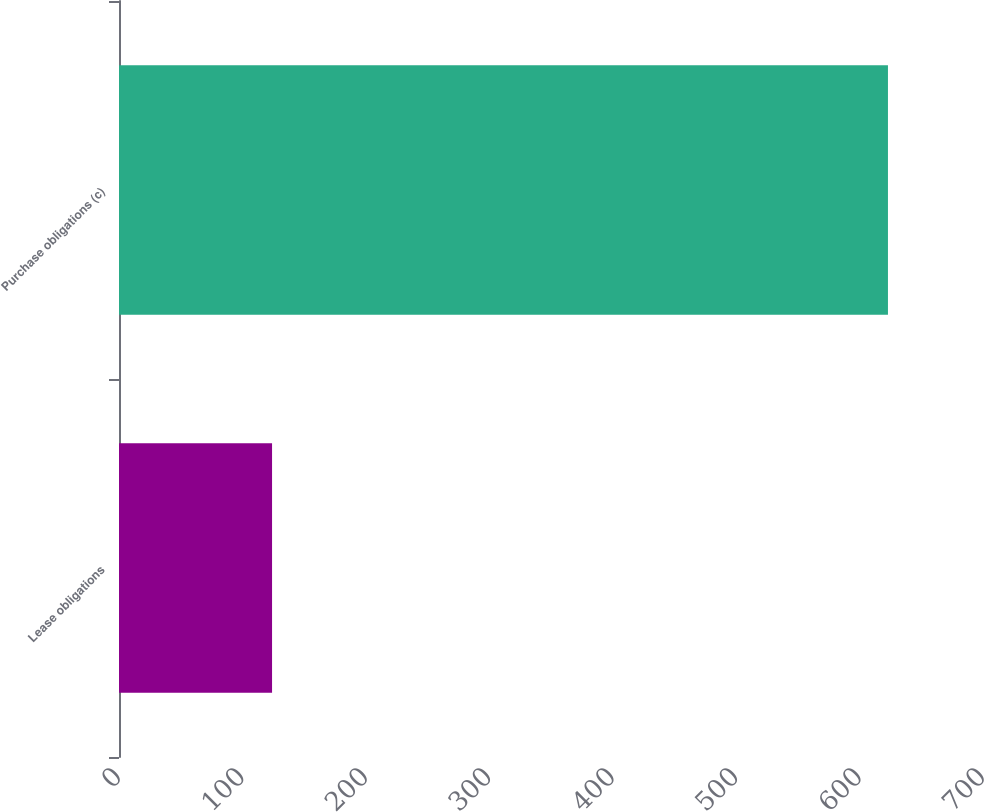<chart> <loc_0><loc_0><loc_500><loc_500><bar_chart><fcel>Lease obligations<fcel>Purchase obligations (c)<nl><fcel>124<fcel>623<nl></chart> 